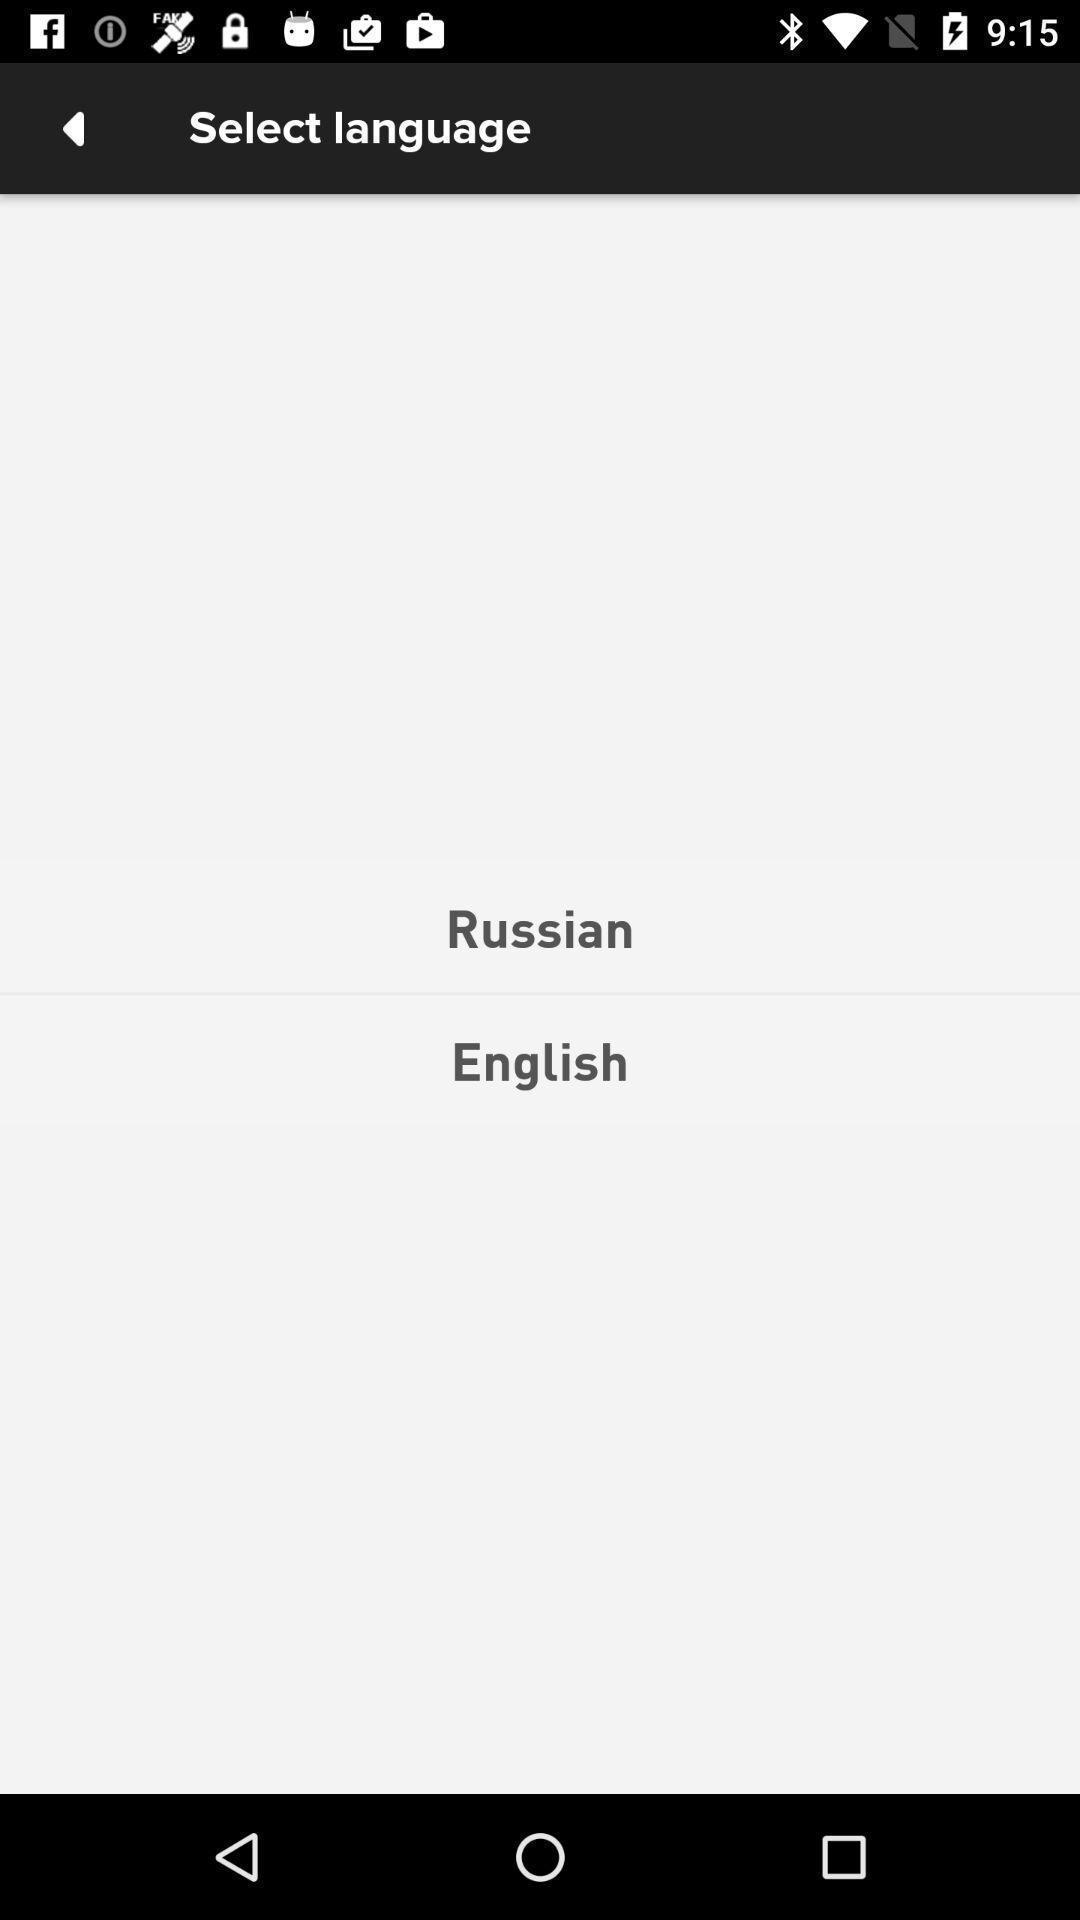Tell me about the visual elements in this screen capture. Page showing different options in selecting language. 